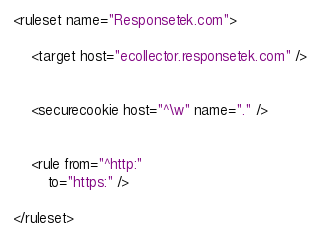<code> <loc_0><loc_0><loc_500><loc_500><_XML_><ruleset name="Responsetek.com">

	<target host="ecollector.responsetek.com" />


	<securecookie host="^\w" name="." />


	<rule from="^http:"
		to="https:" />

</ruleset>
</code> 